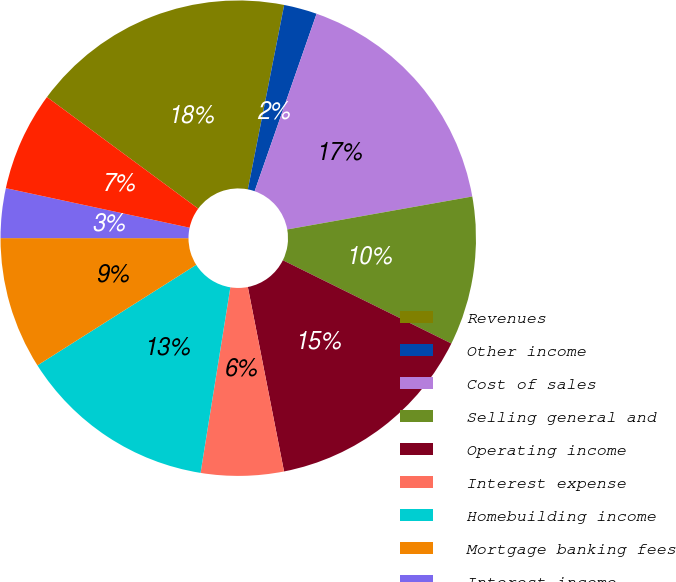<chart> <loc_0><loc_0><loc_500><loc_500><pie_chart><fcel>Revenues<fcel>Other income<fcel>Cost of sales<fcel>Selling general and<fcel>Operating income<fcel>Interest expense<fcel>Homebuilding income<fcel>Mortgage banking fees<fcel>Interest income<fcel>General and administrative<nl><fcel>17.98%<fcel>2.25%<fcel>16.85%<fcel>10.11%<fcel>14.61%<fcel>5.62%<fcel>13.48%<fcel>8.99%<fcel>3.37%<fcel>6.74%<nl></chart> 